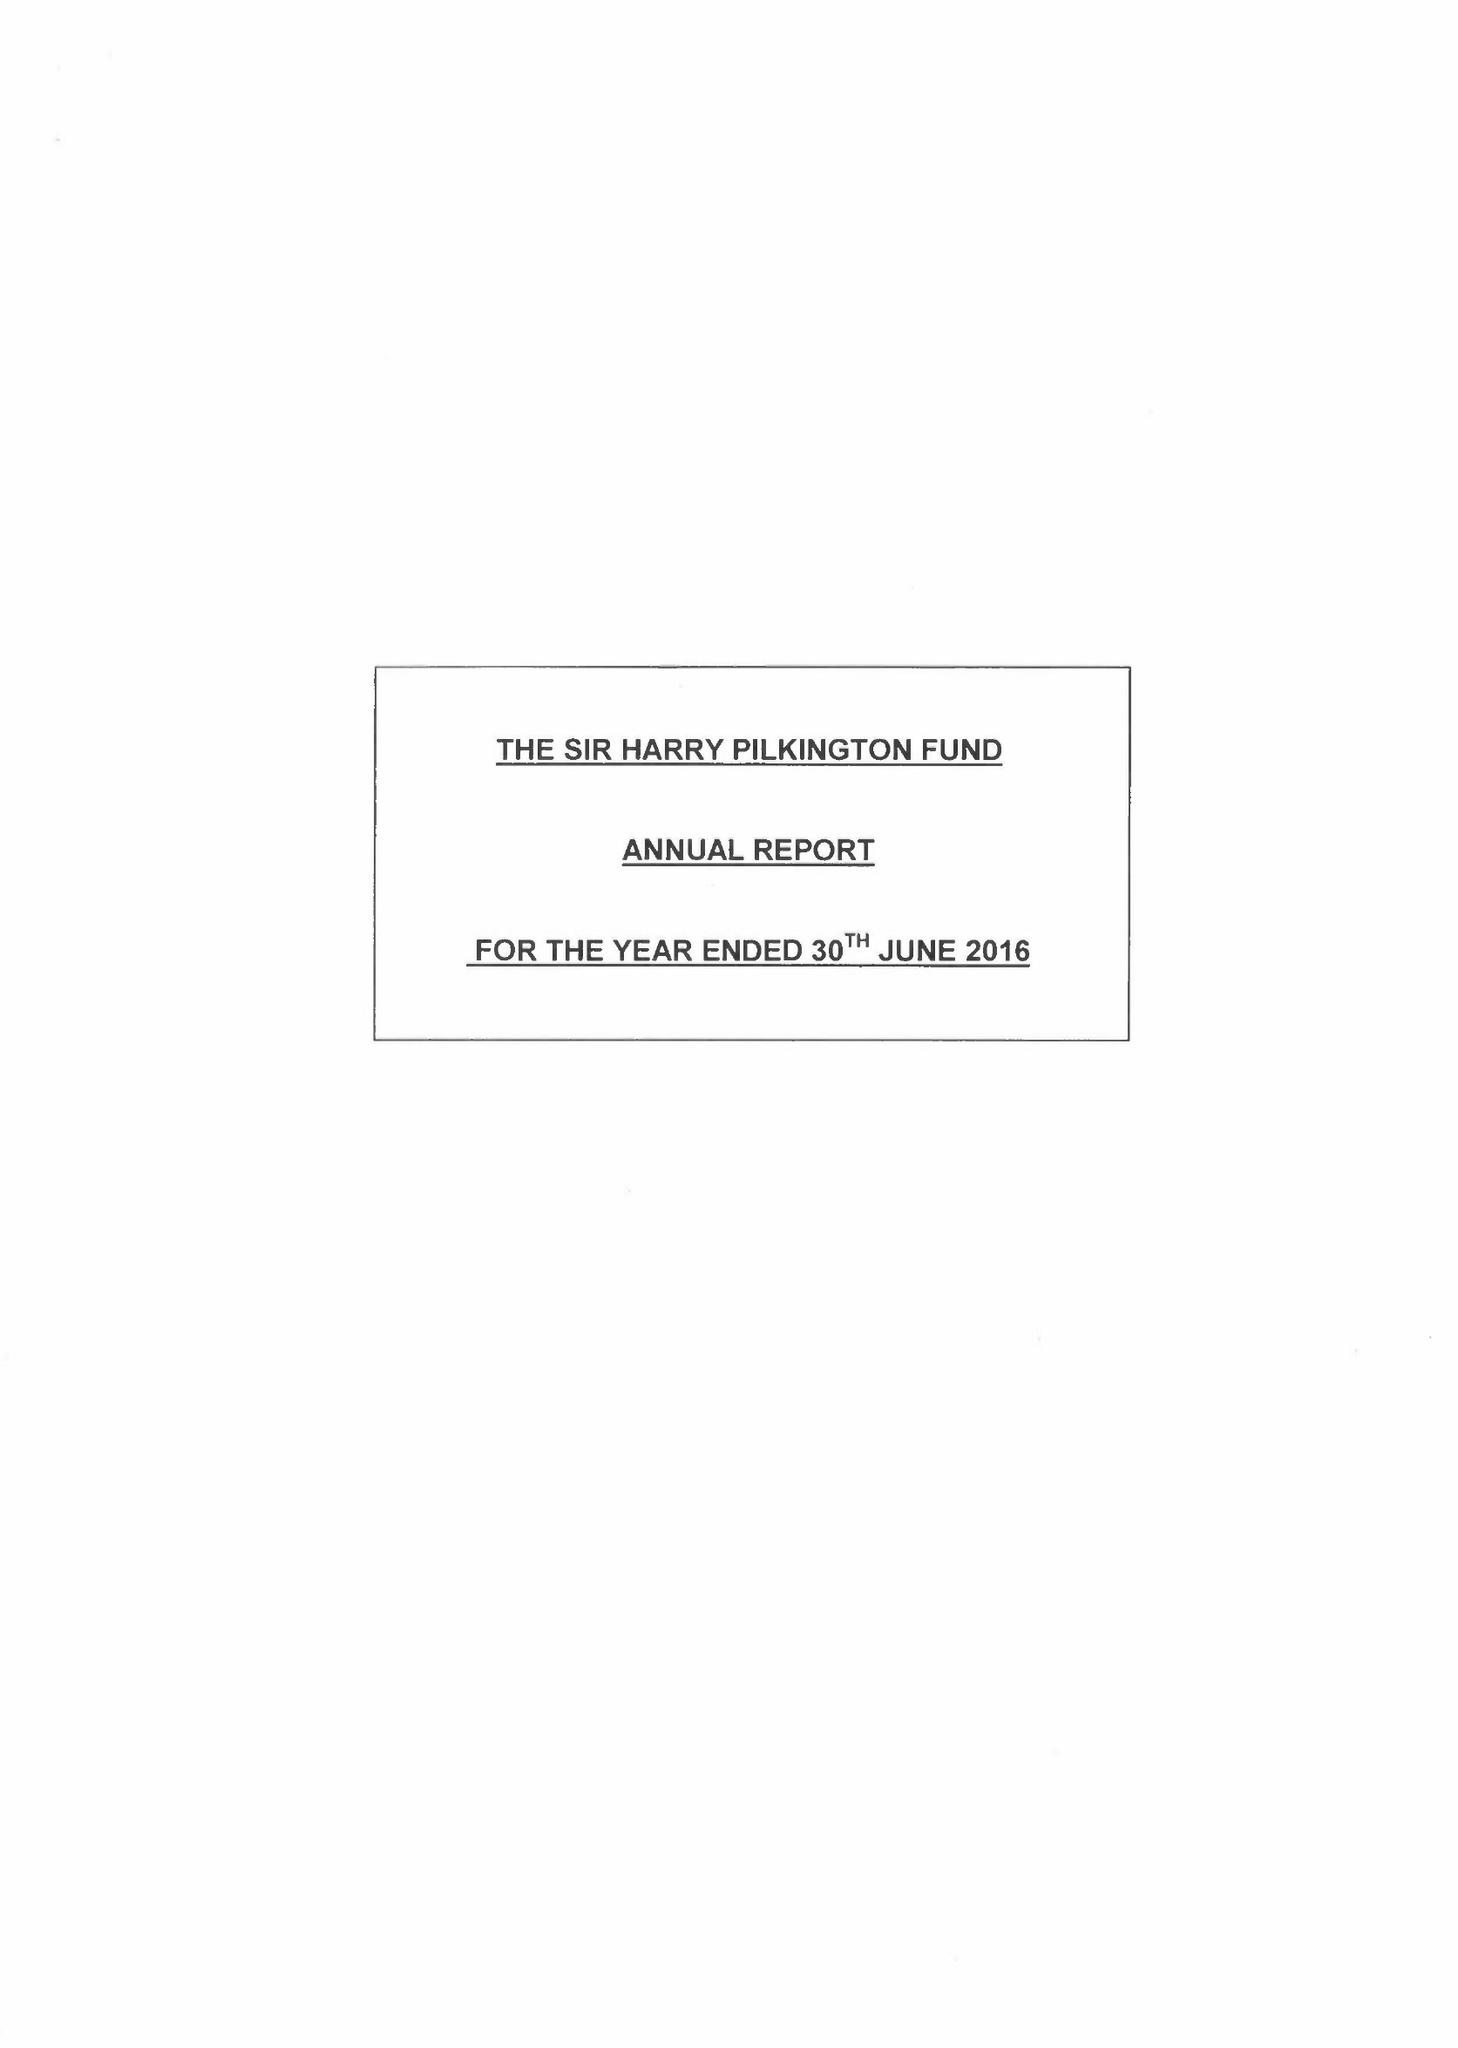What is the value for the charity_number?
Answer the question using a single word or phrase. 206740 